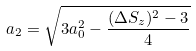<formula> <loc_0><loc_0><loc_500><loc_500>a _ { 2 } = \sqrt { 3 a _ { 0 } ^ { 2 } - \frac { ( \Delta S _ { z } ) ^ { 2 } - 3 } { 4 } }</formula> 